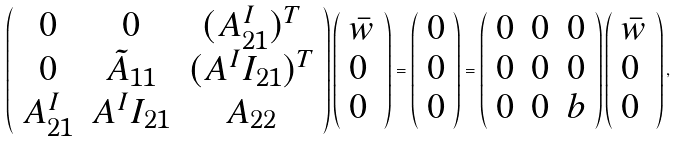<formula> <loc_0><loc_0><loc_500><loc_500>\left ( \begin{array} { c c c } 0 & 0 & ( A _ { 2 1 } ^ { I } ) ^ { T } \\ 0 & \tilde { A } _ { 1 1 } & ( { A } ^ { I } I _ { 2 1 } ) ^ { T } \\ A ^ { I } _ { 2 1 } & A ^ { I } I _ { 2 1 } & A _ { 2 2 } \\ \end{array} \right ) \left ( \begin{array} { l l l } \bar { w } \\ 0 \\ 0 \end{array} \right ) = \left ( \begin{array} { l l l } 0 \\ 0 \\ 0 \\ \end{array} \right ) = \left ( \begin{array} { c c c } 0 & 0 & 0 \\ 0 & 0 & 0 \\ 0 & 0 & b \end{array} \right ) \left ( \begin{array} { l l l } \bar { w } \\ 0 \\ 0 \end{array} \right ) ,</formula> 